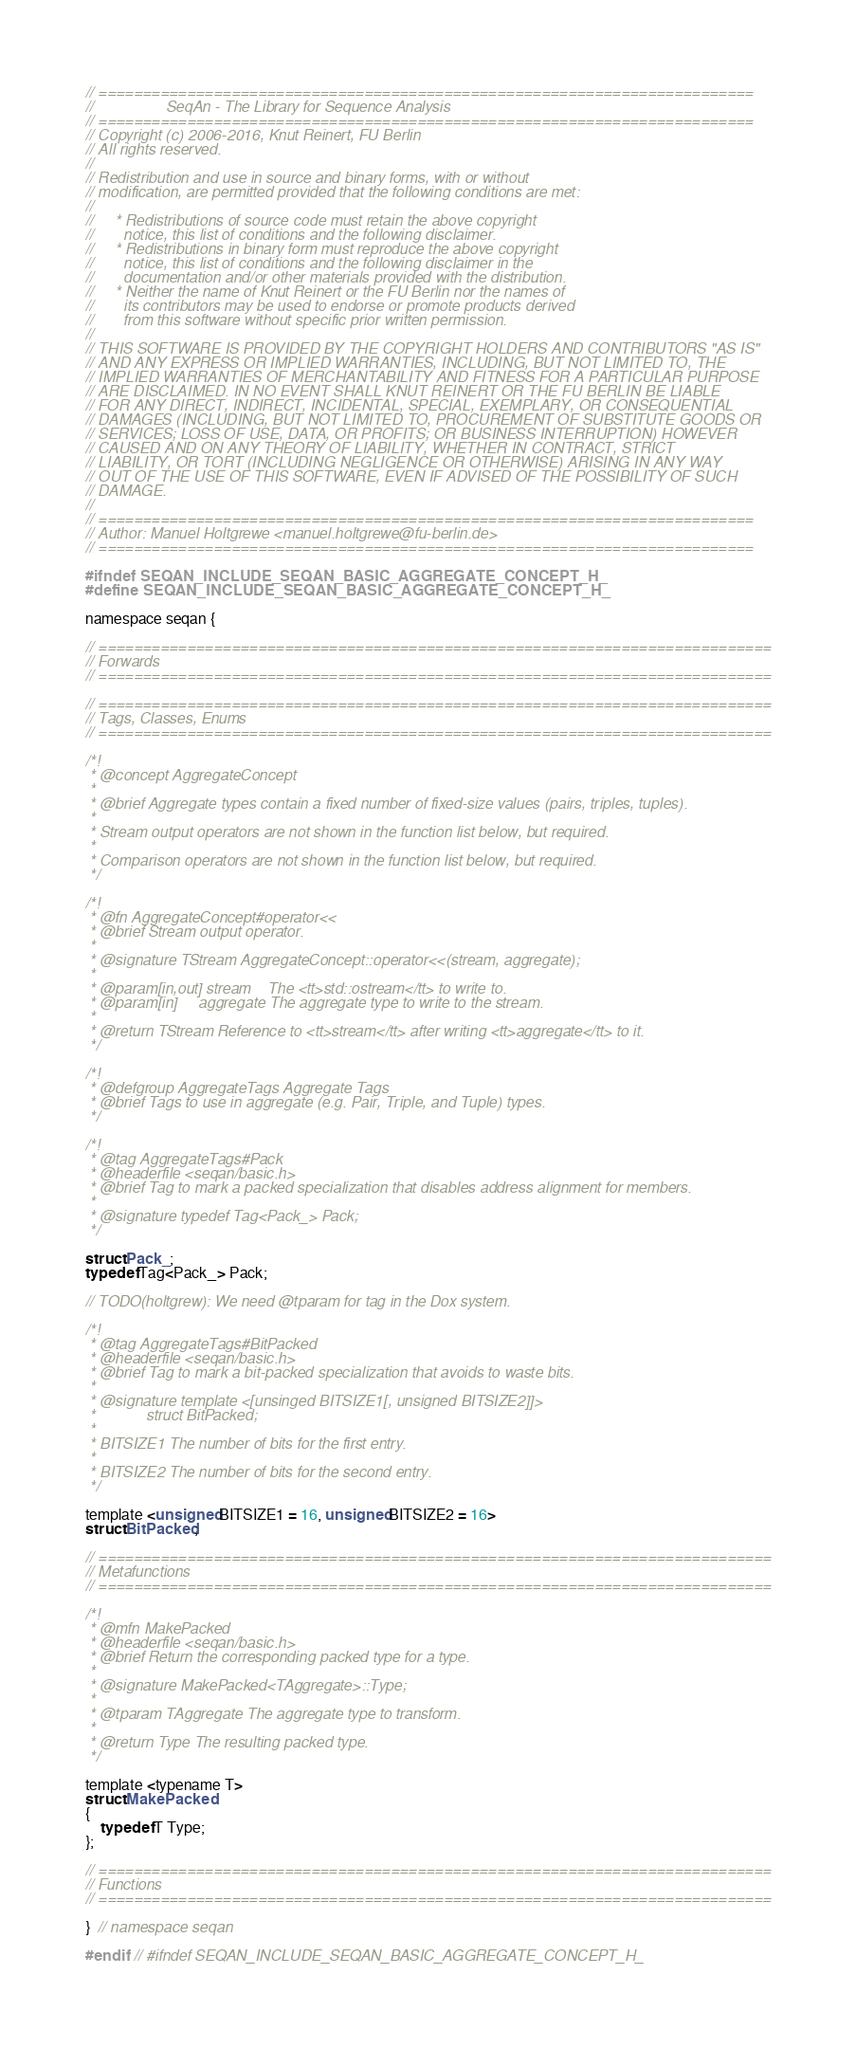<code> <loc_0><loc_0><loc_500><loc_500><_C_>// ==========================================================================
//                 SeqAn - The Library for Sequence Analysis
// ==========================================================================
// Copyright (c) 2006-2016, Knut Reinert, FU Berlin
// All rights reserved.
//
// Redistribution and use in source and binary forms, with or without
// modification, are permitted provided that the following conditions are met:
//
//     * Redistributions of source code must retain the above copyright
//       notice, this list of conditions and the following disclaimer.
//     * Redistributions in binary form must reproduce the above copyright
//       notice, this list of conditions and the following disclaimer in the
//       documentation and/or other materials provided with the distribution.
//     * Neither the name of Knut Reinert or the FU Berlin nor the names of
//       its contributors may be used to endorse or promote products derived
//       from this software without specific prior written permission.
//
// THIS SOFTWARE IS PROVIDED BY THE COPYRIGHT HOLDERS AND CONTRIBUTORS "AS IS"
// AND ANY EXPRESS OR IMPLIED WARRANTIES, INCLUDING, BUT NOT LIMITED TO, THE
// IMPLIED WARRANTIES OF MERCHANTABILITY AND FITNESS FOR A PARTICULAR PURPOSE
// ARE DISCLAIMED. IN NO EVENT SHALL KNUT REINERT OR THE FU BERLIN BE LIABLE
// FOR ANY DIRECT, INDIRECT, INCIDENTAL, SPECIAL, EXEMPLARY, OR CONSEQUENTIAL
// DAMAGES (INCLUDING, BUT NOT LIMITED TO, PROCUREMENT OF SUBSTITUTE GOODS OR
// SERVICES; LOSS OF USE, DATA, OR PROFITS; OR BUSINESS INTERRUPTION) HOWEVER
// CAUSED AND ON ANY THEORY OF LIABILITY, WHETHER IN CONTRACT, STRICT
// LIABILITY, OR TORT (INCLUDING NEGLIGENCE OR OTHERWISE) ARISING IN ANY WAY
// OUT OF THE USE OF THIS SOFTWARE, EVEN IF ADVISED OF THE POSSIBILITY OF SUCH
// DAMAGE.
//
// ==========================================================================
// Author: Manuel Holtgrewe <manuel.holtgrewe@fu-berlin.de>
// ==========================================================================

#ifndef SEQAN_INCLUDE_SEQAN_BASIC_AGGREGATE_CONCEPT_H_
#define SEQAN_INCLUDE_SEQAN_BASIC_AGGREGATE_CONCEPT_H_

namespace seqan {

// ============================================================================
// Forwards
// ============================================================================

// ============================================================================
// Tags, Classes, Enums
// ============================================================================

/*!
 * @concept AggregateConcept
 *
 * @brief Aggregate types contain a fixed number of fixed-size values (pairs, triples, tuples).
 *
 * Stream output operators are not shown in the function list below, but required.
 *
 * Comparison operators are not shown in the function list below, but required.
 */

/*!
 * @fn AggregateConcept#operator<<
 * @brief Stream output operator.
 *
 * @signature TStream AggregateConcept::operator<<(stream, aggregate);
 *
 * @param[in,out] stream    The <tt>std::ostream</tt> to write to.
 * @param[in]     aggregate The aggregate type to write to the stream.
 *
 * @return TStream Reference to <tt>stream</tt> after writing <tt>aggregate</tt> to it.
 */

/*!
 * @defgroup AggregateTags Aggregate Tags
 * @brief Tags to use in aggregate (e.g. Pair, Triple, and Tuple) types.
 */

/*!
 * @tag AggregateTags#Pack
 * @headerfile <seqan/basic.h>
 * @brief Tag to mark a packed specialization that disables address alignment for members.
 *
 * @signature typedef Tag<Pack_> Pack;
 */

struct Pack_;
typedef Tag<Pack_> Pack;

// TODO(holtgrew): We need @tparam for tag in the Dox system.

/*!
 * @tag AggregateTags#BitPacked
 * @headerfile <seqan/basic.h>
 * @brief Tag to mark a bit-packed specialization that avoids to waste bits.
 *
 * @signature template <[unsinged BITSIZE1[, unsigned BITSIZE2]]>
 *            struct BitPacked;
 *
 * BITSIZE1 The number of bits for the first entry.
 *
 * BITSIZE2 The number of bits for the second entry.
 */

template <unsigned BITSIZE1 = 16, unsigned BITSIZE2 = 16>
struct BitPacked;

// ============================================================================
// Metafunctions
// ============================================================================

/*!
 * @mfn MakePacked
 * @headerfile <seqan/basic.h>
 * @brief Return the corresponding packed type for a type.
 *
 * @signature MakePacked<TAggregate>::Type;
 *
 * @tparam TAggregate The aggregate type to transform.
 *
 * @return Type The resulting packed type.
 */

template <typename T>
struct MakePacked
{
    typedef T Type;
};

// ============================================================================
// Functions
// ============================================================================

}  // namespace seqan

#endif  // #ifndef SEQAN_INCLUDE_SEQAN_BASIC_AGGREGATE_CONCEPT_H_
</code> 